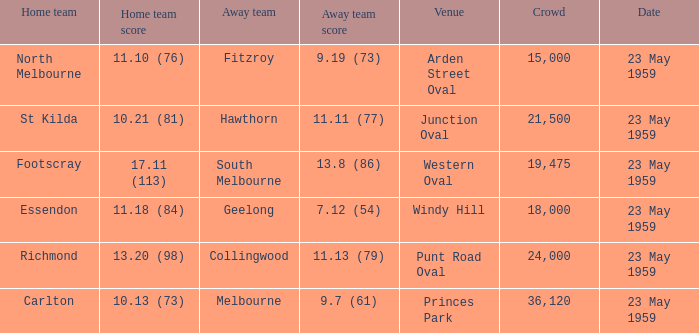What was the home team's score at the game that had a crowd larger than 24,000? 10.13 (73). Could you parse the entire table as a dict? {'header': ['Home team', 'Home team score', 'Away team', 'Away team score', 'Venue', 'Crowd', 'Date'], 'rows': [['North Melbourne', '11.10 (76)', 'Fitzroy', '9.19 (73)', 'Arden Street Oval', '15,000', '23 May 1959'], ['St Kilda', '10.21 (81)', 'Hawthorn', '11.11 (77)', 'Junction Oval', '21,500', '23 May 1959'], ['Footscray', '17.11 (113)', 'South Melbourne', '13.8 (86)', 'Western Oval', '19,475', '23 May 1959'], ['Essendon', '11.18 (84)', 'Geelong', '7.12 (54)', 'Windy Hill', '18,000', '23 May 1959'], ['Richmond', '13.20 (98)', 'Collingwood', '11.13 (79)', 'Punt Road Oval', '24,000', '23 May 1959'], ['Carlton', '10.13 (73)', 'Melbourne', '9.7 (61)', 'Princes Park', '36,120', '23 May 1959']]} 